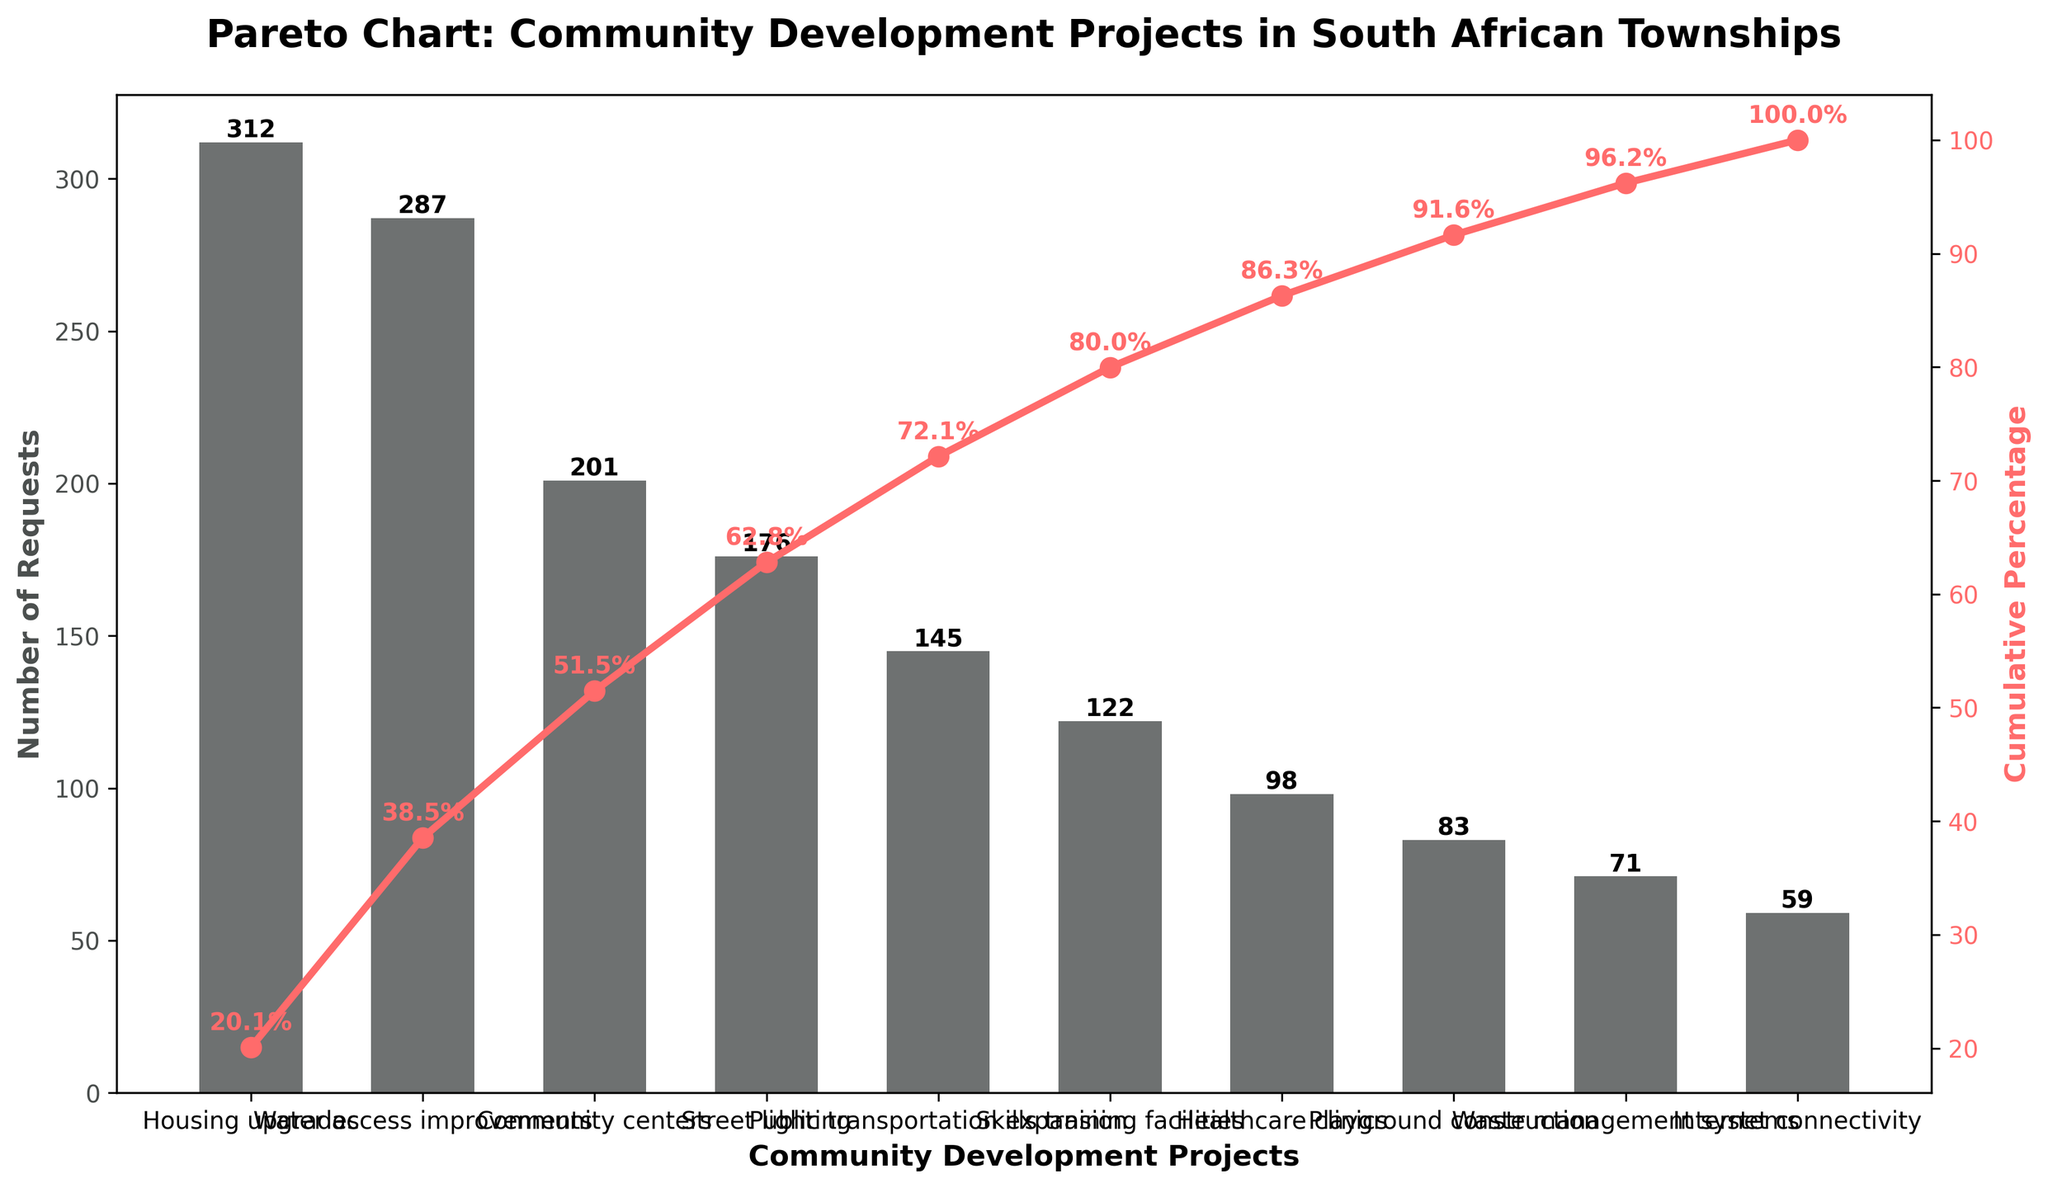What is the most requested community development project in South African townships? The most requested project is easily identified as the tallest bar on the chart, which is "Housing upgrades."
Answer: Housing upgrades What is the cumulative percentage of requests after the top three projects? The cumulative percentage is illustrated by the line plot. After the first three projects (Housing upgrades, Water access improvements, Community centers), the cumulative percentage reaches around 66%.
Answer: 66% How many requests were there for Skills training facilities? The bar corresponding to Skills training facilities shows the height, which is labeled as 122.
Answer: 122 Which project has fewer requests: Playground construction or Internet connectivity? By comparing the height of the bars and their respective numbers, Playground construction has 83 requests while Internet connectivity has 59 requests. Thus, Internet connectivity has fewer requests.
Answer: Internet connectivity What is the cumulative percentage for Healthcare clinics? By looking at the line plot, Healthcare clinics are the seventh project and the cumulative percentage at this point is labeled around 93%.
Answer: 93% Which project has the smallest number of requests? The bar with the smallest height corresponds to "Internet connectivity" with 59 requests.
Answer: Internet connectivity What percentage of total requests do Housing upgrades and Water access improvements account for together? The sum of requests for Housing upgrades (312) and Water access improvements (287) is 599. The total number of requests is the sum of all bars, which is 1454. Therefore, the percentage is (599/1454)*100 ≈ 41.2%.
Answer: 41.2% What is the total number of requests for the projects that received fewer than 100 requests each? The projects with fewer than 100 requests are Healthcare clinics (98), Playground construction (83), Waste management systems (71), and Internet connectivity (59). Adding these: 98 + 83 + 71 + 59 = 311.
Answer: 311 Which project is closest to reaching the cumulative 50% threshold? Observing the line plot, the cumulative 50% threshold is crossed between Water access improvements and Community centers. Water access improvements is the last project before the threshold is reached.
Answer: Water access improvements In which project does the cumulative percentage first exceed 75%? According to the line plot, the cumulative percentage first exceeds 75% after Skills training facilities.
Answer: Skills training facilities 